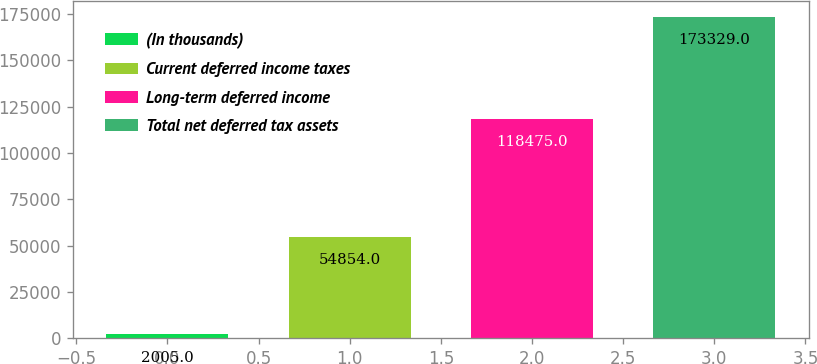<chart> <loc_0><loc_0><loc_500><loc_500><bar_chart><fcel>(In thousands)<fcel>Current deferred income taxes<fcel>Long-term deferred income<fcel>Total net deferred tax assets<nl><fcel>2005<fcel>54854<fcel>118475<fcel>173329<nl></chart> 